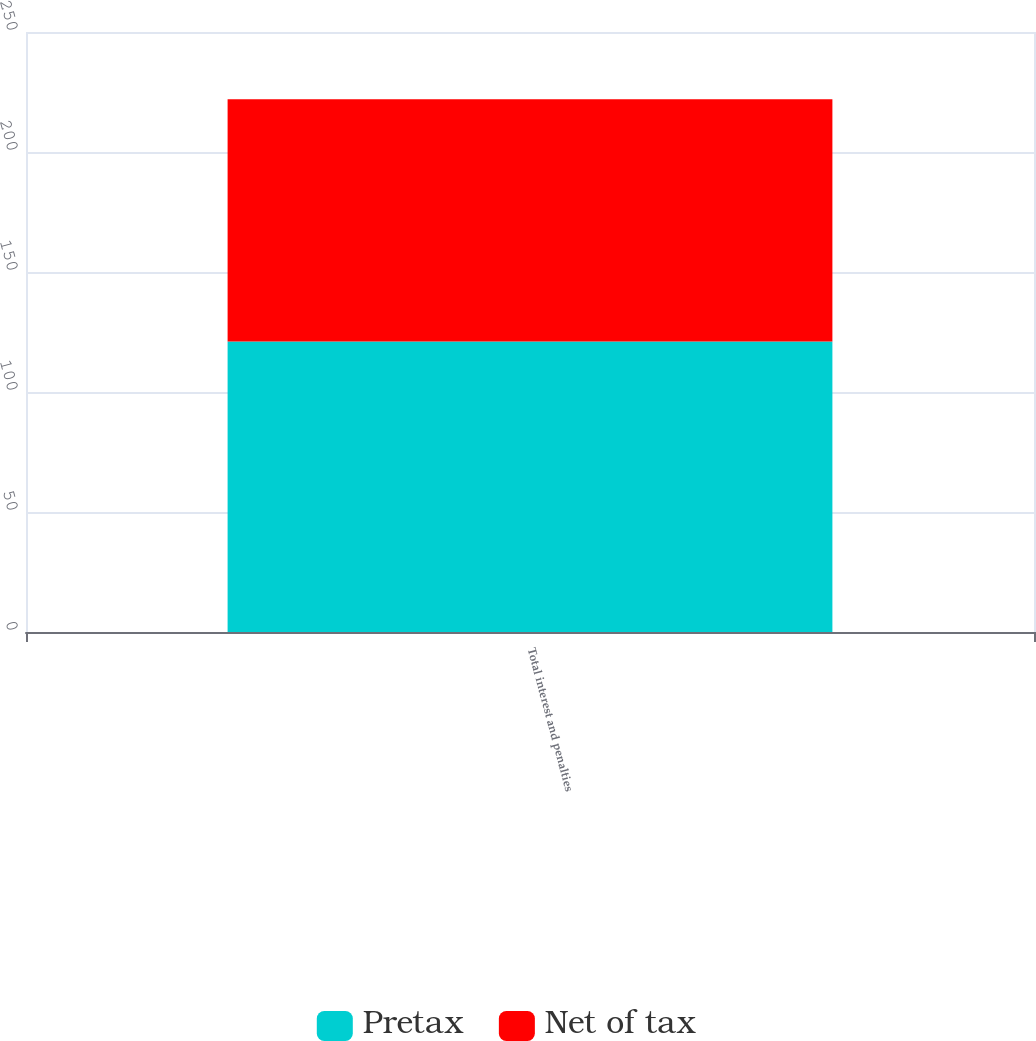Convert chart to OTSL. <chart><loc_0><loc_0><loc_500><loc_500><stacked_bar_chart><ecel><fcel>Total interest and penalties<nl><fcel>Pretax<fcel>121<nl><fcel>Net of tax<fcel>101<nl></chart> 